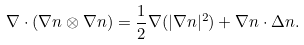<formula> <loc_0><loc_0><loc_500><loc_500>\nabla \cdot ( \nabla n \otimes \nabla n ) = \frac { 1 } { 2 } \nabla ( | \nabla n | ^ { 2 } ) + \nabla n \cdot \Delta n .</formula> 